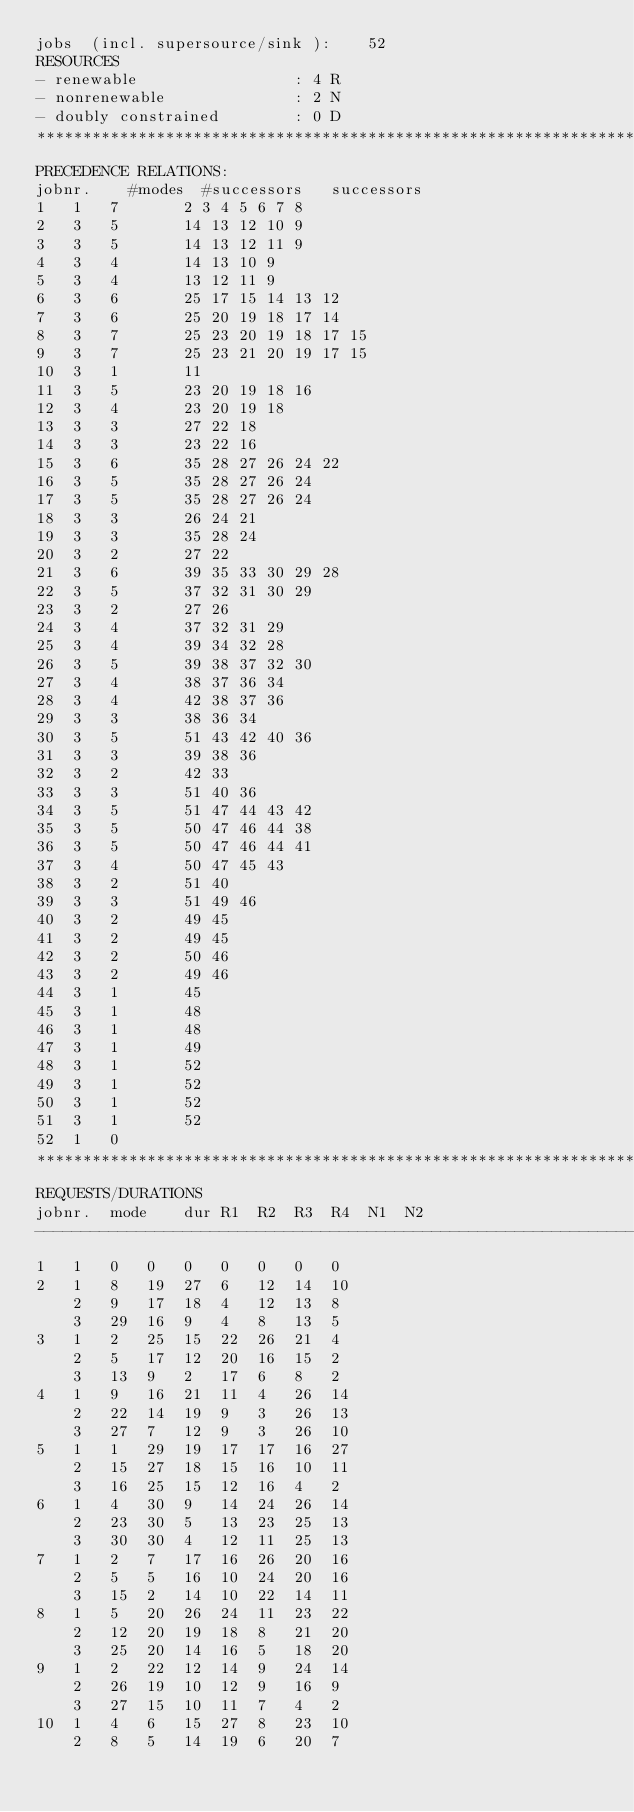<code> <loc_0><loc_0><loc_500><loc_500><_ObjectiveC_>jobs  (incl. supersource/sink ):	52
RESOURCES
- renewable                 : 4 R
- nonrenewable              : 2 N
- doubly constrained        : 0 D
************************************************************************
PRECEDENCE RELATIONS:
jobnr.    #modes  #successors   successors
1	1	7		2 3 4 5 6 7 8 
2	3	5		14 13 12 10 9 
3	3	5		14 13 12 11 9 
4	3	4		14 13 10 9 
5	3	4		13 12 11 9 
6	3	6		25 17 15 14 13 12 
7	3	6		25 20 19 18 17 14 
8	3	7		25 23 20 19 18 17 15 
9	3	7		25 23 21 20 19 17 15 
10	3	1		11 
11	3	5		23 20 19 18 16 
12	3	4		23 20 19 18 
13	3	3		27 22 18 
14	3	3		23 22 16 
15	3	6		35 28 27 26 24 22 
16	3	5		35 28 27 26 24 
17	3	5		35 28 27 26 24 
18	3	3		26 24 21 
19	3	3		35 28 24 
20	3	2		27 22 
21	3	6		39 35 33 30 29 28 
22	3	5		37 32 31 30 29 
23	3	2		27 26 
24	3	4		37 32 31 29 
25	3	4		39 34 32 28 
26	3	5		39 38 37 32 30 
27	3	4		38 37 36 34 
28	3	4		42 38 37 36 
29	3	3		38 36 34 
30	3	5		51 43 42 40 36 
31	3	3		39 38 36 
32	3	2		42 33 
33	3	3		51 40 36 
34	3	5		51 47 44 43 42 
35	3	5		50 47 46 44 38 
36	3	5		50 47 46 44 41 
37	3	4		50 47 45 43 
38	3	2		51 40 
39	3	3		51 49 46 
40	3	2		49 45 
41	3	2		49 45 
42	3	2		50 46 
43	3	2		49 46 
44	3	1		45 
45	3	1		48 
46	3	1		48 
47	3	1		49 
48	3	1		52 
49	3	1		52 
50	3	1		52 
51	3	1		52 
52	1	0		
************************************************************************
REQUESTS/DURATIONS
jobnr.	mode	dur	R1	R2	R3	R4	N1	N2	
------------------------------------------------------------------------
1	1	0	0	0	0	0	0	0	
2	1	8	19	27	6	12	14	10	
	2	9	17	18	4	12	13	8	
	3	29	16	9	4	8	13	5	
3	1	2	25	15	22	26	21	4	
	2	5	17	12	20	16	15	2	
	3	13	9	2	17	6	8	2	
4	1	9	16	21	11	4	26	14	
	2	22	14	19	9	3	26	13	
	3	27	7	12	9	3	26	10	
5	1	1	29	19	17	17	16	27	
	2	15	27	18	15	16	10	11	
	3	16	25	15	12	16	4	2	
6	1	4	30	9	14	24	26	14	
	2	23	30	5	13	23	25	13	
	3	30	30	4	12	11	25	13	
7	1	2	7	17	16	26	20	16	
	2	5	5	16	10	24	20	16	
	3	15	2	14	10	22	14	11	
8	1	5	20	26	24	11	23	22	
	2	12	20	19	18	8	21	20	
	3	25	20	14	16	5	18	20	
9	1	2	22	12	14	9	24	14	
	2	26	19	10	12	9	16	9	
	3	27	15	10	11	7	4	2	
10	1	4	6	15	27	8	23	10	
	2	8	5	14	19	6	20	7	</code> 